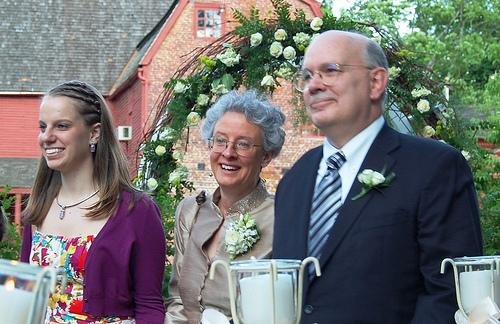Identify any distinct object corners or details in the image. Some distinct object details to notice include the edge of a coat, part of a handle, and part of a flower. Give a description of the archway in the image and its surrounding decorations. The archway is decorated with flowers and wicker, and there is a rose wreath behind the people. Describe the three people present in the image and their positions. An old man is in the center, an old woman is on the right wearing glasses, and a young woman in a purple sweater is on the left. What kind of clothing is the young woman wearing? The young woman is wearing a purple sweater and a brightly colored dress. What color are the flowers on the archway and where are they located? The flowers on the archway are white and they are situated towards the top of the structure. Can you identify the apparel worn by the old man? The old man is wearing a suit jacket with a flower on it and glasses on his face. Describe the accessories worn by the old woman. The old woman is wearing glasses on her face, an earring in her ear, and a necklace around her neck. Provide a brief description of the overall scene in the image. The image captures a celebration at a wedding ceremony with three people, an archway with flowers, and various clothing and accessories details. What kind of event is taking place in the picture? The picture features a wedding celebration and ceremony with three attendees. Mention one primary object in the image and its main attributes. There is an old man wearing glasses and a suit jacket with a flower on it, standing in the center of the image. 